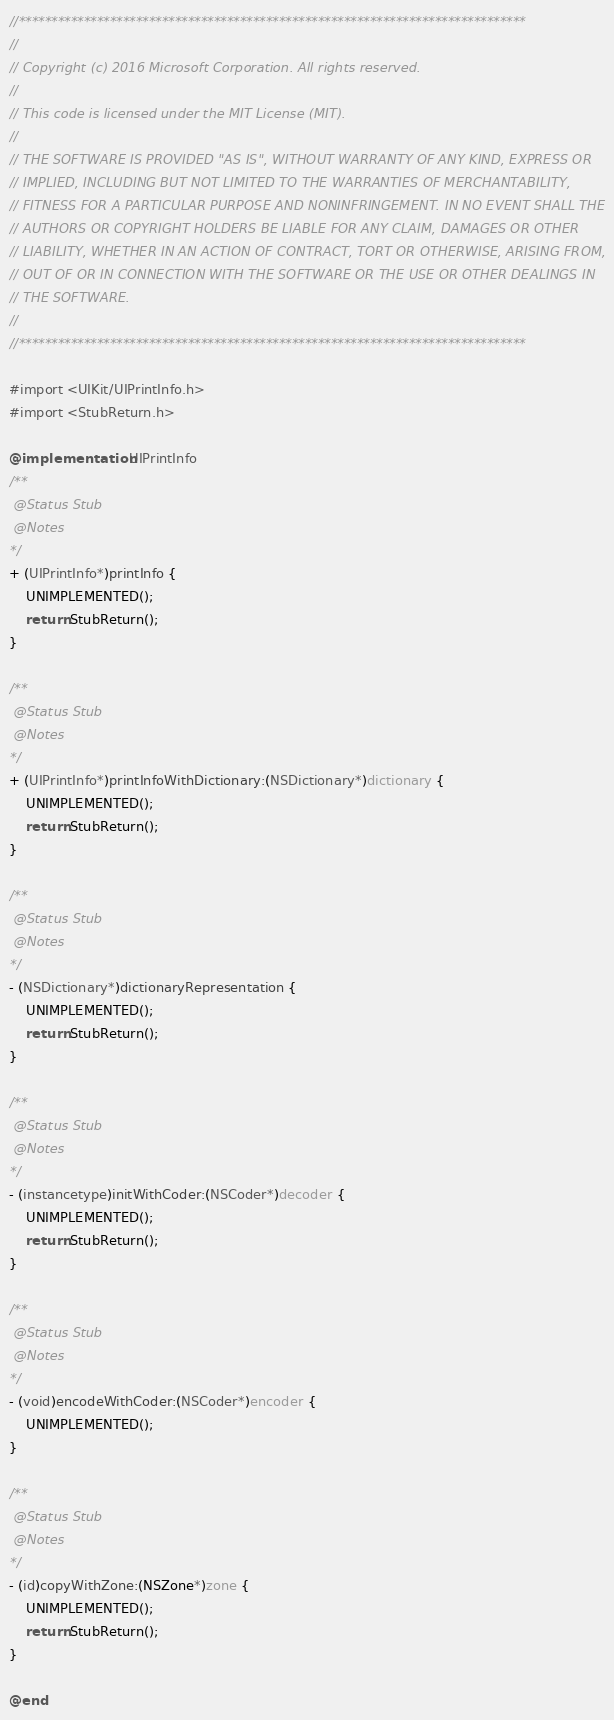Convert code to text. <code><loc_0><loc_0><loc_500><loc_500><_ObjectiveC_>//******************************************************************************
//
// Copyright (c) 2016 Microsoft Corporation. All rights reserved.
//
// This code is licensed under the MIT License (MIT).
//
// THE SOFTWARE IS PROVIDED "AS IS", WITHOUT WARRANTY OF ANY KIND, EXPRESS OR
// IMPLIED, INCLUDING BUT NOT LIMITED TO THE WARRANTIES OF MERCHANTABILITY,
// FITNESS FOR A PARTICULAR PURPOSE AND NONINFRINGEMENT. IN NO EVENT SHALL THE
// AUTHORS OR COPYRIGHT HOLDERS BE LIABLE FOR ANY CLAIM, DAMAGES OR OTHER
// LIABILITY, WHETHER IN AN ACTION OF CONTRACT, TORT OR OTHERWISE, ARISING FROM,
// OUT OF OR IN CONNECTION WITH THE SOFTWARE OR THE USE OR OTHER DEALINGS IN
// THE SOFTWARE.
//
//******************************************************************************

#import <UIKit/UIPrintInfo.h>
#import <StubReturn.h>

@implementation UIPrintInfo
/**
 @Status Stub
 @Notes
*/
+ (UIPrintInfo*)printInfo {
    UNIMPLEMENTED();
    return StubReturn();
}

/**
 @Status Stub
 @Notes
*/
+ (UIPrintInfo*)printInfoWithDictionary:(NSDictionary*)dictionary {
    UNIMPLEMENTED();
    return StubReturn();
}

/**
 @Status Stub
 @Notes
*/
- (NSDictionary*)dictionaryRepresentation {
    UNIMPLEMENTED();
    return StubReturn();
}

/**
 @Status Stub
 @Notes
*/
- (instancetype)initWithCoder:(NSCoder*)decoder {
    UNIMPLEMENTED();
    return StubReturn();
}

/**
 @Status Stub
 @Notes
*/
- (void)encodeWithCoder:(NSCoder*)encoder {
    UNIMPLEMENTED();
}

/**
 @Status Stub
 @Notes
*/
- (id)copyWithZone:(NSZone*)zone {
    UNIMPLEMENTED();
    return StubReturn();
}

@end
</code> 